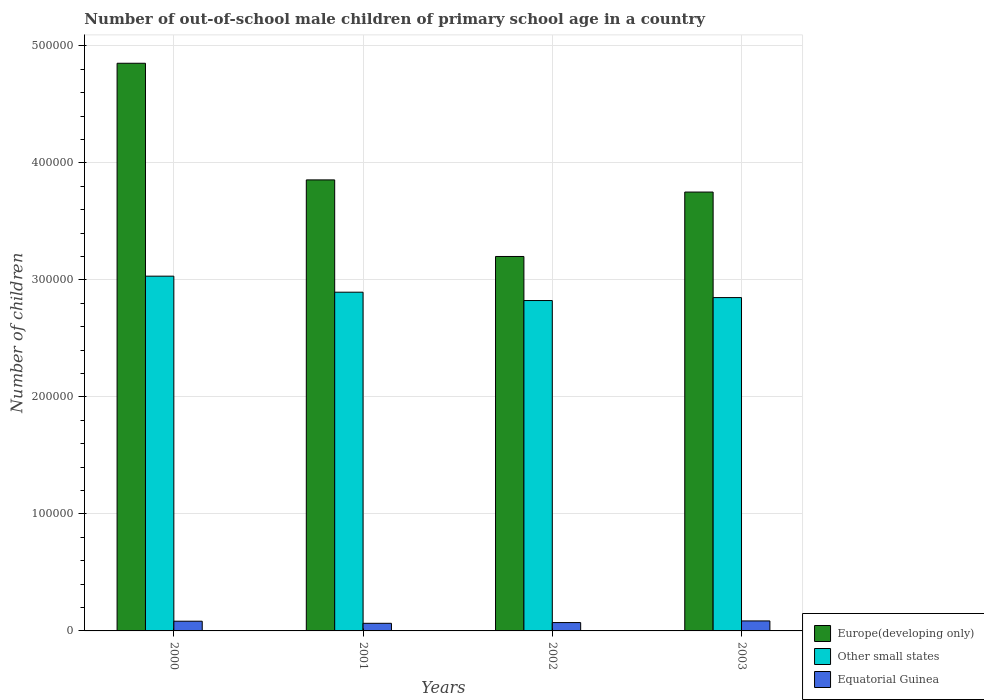How many groups of bars are there?
Provide a succinct answer. 4. Are the number of bars per tick equal to the number of legend labels?
Offer a terse response. Yes. Are the number of bars on each tick of the X-axis equal?
Keep it short and to the point. Yes. How many bars are there on the 2nd tick from the left?
Your answer should be compact. 3. How many bars are there on the 4th tick from the right?
Provide a succinct answer. 3. What is the label of the 1st group of bars from the left?
Ensure brevity in your answer.  2000. What is the number of out-of-school male children in Other small states in 2003?
Offer a terse response. 2.85e+05. Across all years, what is the maximum number of out-of-school male children in Equatorial Guinea?
Make the answer very short. 8538. Across all years, what is the minimum number of out-of-school male children in Europe(developing only)?
Provide a short and direct response. 3.20e+05. What is the total number of out-of-school male children in Equatorial Guinea in the graph?
Make the answer very short. 3.05e+04. What is the difference between the number of out-of-school male children in Equatorial Guinea in 2002 and that in 2003?
Your answer should be compact. -1403. What is the difference between the number of out-of-school male children in Europe(developing only) in 2000 and the number of out-of-school male children in Equatorial Guinea in 2003?
Your response must be concise. 4.77e+05. What is the average number of out-of-school male children in Europe(developing only) per year?
Your answer should be very brief. 3.91e+05. In the year 2002, what is the difference between the number of out-of-school male children in Other small states and number of out-of-school male children in Equatorial Guinea?
Your answer should be very brief. 2.75e+05. What is the ratio of the number of out-of-school male children in Other small states in 2000 to that in 2001?
Provide a succinct answer. 1.05. Is the number of out-of-school male children in Equatorial Guinea in 2000 less than that in 2003?
Your answer should be very brief. Yes. Is the difference between the number of out-of-school male children in Other small states in 2000 and 2002 greater than the difference between the number of out-of-school male children in Equatorial Guinea in 2000 and 2002?
Provide a short and direct response. Yes. What is the difference between the highest and the second highest number of out-of-school male children in Other small states?
Make the answer very short. 1.37e+04. What is the difference between the highest and the lowest number of out-of-school male children in Other small states?
Keep it short and to the point. 2.08e+04. In how many years, is the number of out-of-school male children in Equatorial Guinea greater than the average number of out-of-school male children in Equatorial Guinea taken over all years?
Provide a succinct answer. 2. Is the sum of the number of out-of-school male children in Equatorial Guinea in 2000 and 2001 greater than the maximum number of out-of-school male children in Europe(developing only) across all years?
Your response must be concise. No. What does the 3rd bar from the left in 2001 represents?
Ensure brevity in your answer.  Equatorial Guinea. What does the 1st bar from the right in 2003 represents?
Your answer should be very brief. Equatorial Guinea. Are all the bars in the graph horizontal?
Give a very brief answer. No. How many years are there in the graph?
Ensure brevity in your answer.  4. What is the difference between two consecutive major ticks on the Y-axis?
Your response must be concise. 1.00e+05. Are the values on the major ticks of Y-axis written in scientific E-notation?
Your answer should be compact. No. How many legend labels are there?
Your response must be concise. 3. What is the title of the graph?
Your answer should be very brief. Number of out-of-school male children of primary school age in a country. What is the label or title of the X-axis?
Give a very brief answer. Years. What is the label or title of the Y-axis?
Your answer should be compact. Number of children. What is the Number of children in Europe(developing only) in 2000?
Give a very brief answer. 4.85e+05. What is the Number of children of Other small states in 2000?
Offer a terse response. 3.03e+05. What is the Number of children in Equatorial Guinea in 2000?
Provide a succinct answer. 8303. What is the Number of children of Europe(developing only) in 2001?
Keep it short and to the point. 3.85e+05. What is the Number of children in Other small states in 2001?
Your answer should be compact. 2.90e+05. What is the Number of children in Equatorial Guinea in 2001?
Your answer should be compact. 6505. What is the Number of children of Europe(developing only) in 2002?
Your answer should be compact. 3.20e+05. What is the Number of children of Other small states in 2002?
Keep it short and to the point. 2.82e+05. What is the Number of children of Equatorial Guinea in 2002?
Keep it short and to the point. 7135. What is the Number of children of Europe(developing only) in 2003?
Make the answer very short. 3.75e+05. What is the Number of children in Other small states in 2003?
Your response must be concise. 2.85e+05. What is the Number of children of Equatorial Guinea in 2003?
Give a very brief answer. 8538. Across all years, what is the maximum Number of children of Europe(developing only)?
Your response must be concise. 4.85e+05. Across all years, what is the maximum Number of children in Other small states?
Your response must be concise. 3.03e+05. Across all years, what is the maximum Number of children of Equatorial Guinea?
Your response must be concise. 8538. Across all years, what is the minimum Number of children of Europe(developing only)?
Give a very brief answer. 3.20e+05. Across all years, what is the minimum Number of children of Other small states?
Give a very brief answer. 2.82e+05. Across all years, what is the minimum Number of children of Equatorial Guinea?
Make the answer very short. 6505. What is the total Number of children in Europe(developing only) in the graph?
Make the answer very short. 1.57e+06. What is the total Number of children in Other small states in the graph?
Offer a terse response. 1.16e+06. What is the total Number of children in Equatorial Guinea in the graph?
Offer a terse response. 3.05e+04. What is the difference between the Number of children in Europe(developing only) in 2000 and that in 2001?
Provide a short and direct response. 9.97e+04. What is the difference between the Number of children in Other small states in 2000 and that in 2001?
Offer a terse response. 1.37e+04. What is the difference between the Number of children of Equatorial Guinea in 2000 and that in 2001?
Provide a succinct answer. 1798. What is the difference between the Number of children of Europe(developing only) in 2000 and that in 2002?
Make the answer very short. 1.65e+05. What is the difference between the Number of children in Other small states in 2000 and that in 2002?
Offer a terse response. 2.08e+04. What is the difference between the Number of children in Equatorial Guinea in 2000 and that in 2002?
Make the answer very short. 1168. What is the difference between the Number of children in Europe(developing only) in 2000 and that in 2003?
Make the answer very short. 1.10e+05. What is the difference between the Number of children in Other small states in 2000 and that in 2003?
Provide a succinct answer. 1.83e+04. What is the difference between the Number of children in Equatorial Guinea in 2000 and that in 2003?
Your response must be concise. -235. What is the difference between the Number of children of Europe(developing only) in 2001 and that in 2002?
Provide a succinct answer. 6.54e+04. What is the difference between the Number of children of Other small states in 2001 and that in 2002?
Provide a succinct answer. 7131. What is the difference between the Number of children of Equatorial Guinea in 2001 and that in 2002?
Ensure brevity in your answer.  -630. What is the difference between the Number of children of Europe(developing only) in 2001 and that in 2003?
Keep it short and to the point. 1.04e+04. What is the difference between the Number of children of Other small states in 2001 and that in 2003?
Keep it short and to the point. 4598. What is the difference between the Number of children of Equatorial Guinea in 2001 and that in 2003?
Make the answer very short. -2033. What is the difference between the Number of children of Europe(developing only) in 2002 and that in 2003?
Make the answer very short. -5.51e+04. What is the difference between the Number of children of Other small states in 2002 and that in 2003?
Keep it short and to the point. -2533. What is the difference between the Number of children in Equatorial Guinea in 2002 and that in 2003?
Give a very brief answer. -1403. What is the difference between the Number of children in Europe(developing only) in 2000 and the Number of children in Other small states in 2001?
Ensure brevity in your answer.  1.96e+05. What is the difference between the Number of children of Europe(developing only) in 2000 and the Number of children of Equatorial Guinea in 2001?
Your answer should be compact. 4.79e+05. What is the difference between the Number of children of Other small states in 2000 and the Number of children of Equatorial Guinea in 2001?
Your response must be concise. 2.97e+05. What is the difference between the Number of children in Europe(developing only) in 2000 and the Number of children in Other small states in 2002?
Provide a short and direct response. 2.03e+05. What is the difference between the Number of children in Europe(developing only) in 2000 and the Number of children in Equatorial Guinea in 2002?
Ensure brevity in your answer.  4.78e+05. What is the difference between the Number of children of Other small states in 2000 and the Number of children of Equatorial Guinea in 2002?
Your response must be concise. 2.96e+05. What is the difference between the Number of children in Europe(developing only) in 2000 and the Number of children in Other small states in 2003?
Offer a very short reply. 2.00e+05. What is the difference between the Number of children in Europe(developing only) in 2000 and the Number of children in Equatorial Guinea in 2003?
Offer a terse response. 4.77e+05. What is the difference between the Number of children in Other small states in 2000 and the Number of children in Equatorial Guinea in 2003?
Your answer should be very brief. 2.95e+05. What is the difference between the Number of children of Europe(developing only) in 2001 and the Number of children of Other small states in 2002?
Your answer should be very brief. 1.03e+05. What is the difference between the Number of children of Europe(developing only) in 2001 and the Number of children of Equatorial Guinea in 2002?
Ensure brevity in your answer.  3.78e+05. What is the difference between the Number of children of Other small states in 2001 and the Number of children of Equatorial Guinea in 2002?
Provide a succinct answer. 2.82e+05. What is the difference between the Number of children of Europe(developing only) in 2001 and the Number of children of Other small states in 2003?
Your response must be concise. 1.01e+05. What is the difference between the Number of children of Europe(developing only) in 2001 and the Number of children of Equatorial Guinea in 2003?
Offer a terse response. 3.77e+05. What is the difference between the Number of children of Other small states in 2001 and the Number of children of Equatorial Guinea in 2003?
Your answer should be very brief. 2.81e+05. What is the difference between the Number of children of Europe(developing only) in 2002 and the Number of children of Other small states in 2003?
Provide a short and direct response. 3.51e+04. What is the difference between the Number of children in Europe(developing only) in 2002 and the Number of children in Equatorial Guinea in 2003?
Your answer should be very brief. 3.11e+05. What is the difference between the Number of children in Other small states in 2002 and the Number of children in Equatorial Guinea in 2003?
Offer a terse response. 2.74e+05. What is the average Number of children of Europe(developing only) per year?
Your response must be concise. 3.91e+05. What is the average Number of children of Other small states per year?
Offer a very short reply. 2.90e+05. What is the average Number of children of Equatorial Guinea per year?
Provide a short and direct response. 7620.25. In the year 2000, what is the difference between the Number of children of Europe(developing only) and Number of children of Other small states?
Make the answer very short. 1.82e+05. In the year 2000, what is the difference between the Number of children of Europe(developing only) and Number of children of Equatorial Guinea?
Offer a very short reply. 4.77e+05. In the year 2000, what is the difference between the Number of children of Other small states and Number of children of Equatorial Guinea?
Offer a very short reply. 2.95e+05. In the year 2001, what is the difference between the Number of children in Europe(developing only) and Number of children in Other small states?
Ensure brevity in your answer.  9.60e+04. In the year 2001, what is the difference between the Number of children of Europe(developing only) and Number of children of Equatorial Guinea?
Offer a very short reply. 3.79e+05. In the year 2001, what is the difference between the Number of children of Other small states and Number of children of Equatorial Guinea?
Provide a short and direct response. 2.83e+05. In the year 2002, what is the difference between the Number of children of Europe(developing only) and Number of children of Other small states?
Provide a succinct answer. 3.77e+04. In the year 2002, what is the difference between the Number of children in Europe(developing only) and Number of children in Equatorial Guinea?
Your response must be concise. 3.13e+05. In the year 2002, what is the difference between the Number of children in Other small states and Number of children in Equatorial Guinea?
Give a very brief answer. 2.75e+05. In the year 2003, what is the difference between the Number of children in Europe(developing only) and Number of children in Other small states?
Ensure brevity in your answer.  9.02e+04. In the year 2003, what is the difference between the Number of children in Europe(developing only) and Number of children in Equatorial Guinea?
Your response must be concise. 3.67e+05. In the year 2003, what is the difference between the Number of children in Other small states and Number of children in Equatorial Guinea?
Offer a terse response. 2.76e+05. What is the ratio of the Number of children in Europe(developing only) in 2000 to that in 2001?
Your response must be concise. 1.26. What is the ratio of the Number of children of Other small states in 2000 to that in 2001?
Provide a short and direct response. 1.05. What is the ratio of the Number of children in Equatorial Guinea in 2000 to that in 2001?
Your answer should be very brief. 1.28. What is the ratio of the Number of children of Europe(developing only) in 2000 to that in 2002?
Keep it short and to the point. 1.52. What is the ratio of the Number of children in Other small states in 2000 to that in 2002?
Offer a terse response. 1.07. What is the ratio of the Number of children in Equatorial Guinea in 2000 to that in 2002?
Provide a short and direct response. 1.16. What is the ratio of the Number of children of Europe(developing only) in 2000 to that in 2003?
Your answer should be very brief. 1.29. What is the ratio of the Number of children of Other small states in 2000 to that in 2003?
Make the answer very short. 1.06. What is the ratio of the Number of children of Equatorial Guinea in 2000 to that in 2003?
Provide a succinct answer. 0.97. What is the ratio of the Number of children in Europe(developing only) in 2001 to that in 2002?
Give a very brief answer. 1.2. What is the ratio of the Number of children of Other small states in 2001 to that in 2002?
Provide a short and direct response. 1.03. What is the ratio of the Number of children of Equatorial Guinea in 2001 to that in 2002?
Make the answer very short. 0.91. What is the ratio of the Number of children in Europe(developing only) in 2001 to that in 2003?
Offer a very short reply. 1.03. What is the ratio of the Number of children of Other small states in 2001 to that in 2003?
Provide a short and direct response. 1.02. What is the ratio of the Number of children in Equatorial Guinea in 2001 to that in 2003?
Offer a terse response. 0.76. What is the ratio of the Number of children in Europe(developing only) in 2002 to that in 2003?
Offer a terse response. 0.85. What is the ratio of the Number of children in Other small states in 2002 to that in 2003?
Provide a succinct answer. 0.99. What is the ratio of the Number of children in Equatorial Guinea in 2002 to that in 2003?
Keep it short and to the point. 0.84. What is the difference between the highest and the second highest Number of children of Europe(developing only)?
Offer a very short reply. 9.97e+04. What is the difference between the highest and the second highest Number of children in Other small states?
Keep it short and to the point. 1.37e+04. What is the difference between the highest and the second highest Number of children in Equatorial Guinea?
Provide a succinct answer. 235. What is the difference between the highest and the lowest Number of children in Europe(developing only)?
Ensure brevity in your answer.  1.65e+05. What is the difference between the highest and the lowest Number of children of Other small states?
Make the answer very short. 2.08e+04. What is the difference between the highest and the lowest Number of children of Equatorial Guinea?
Offer a very short reply. 2033. 